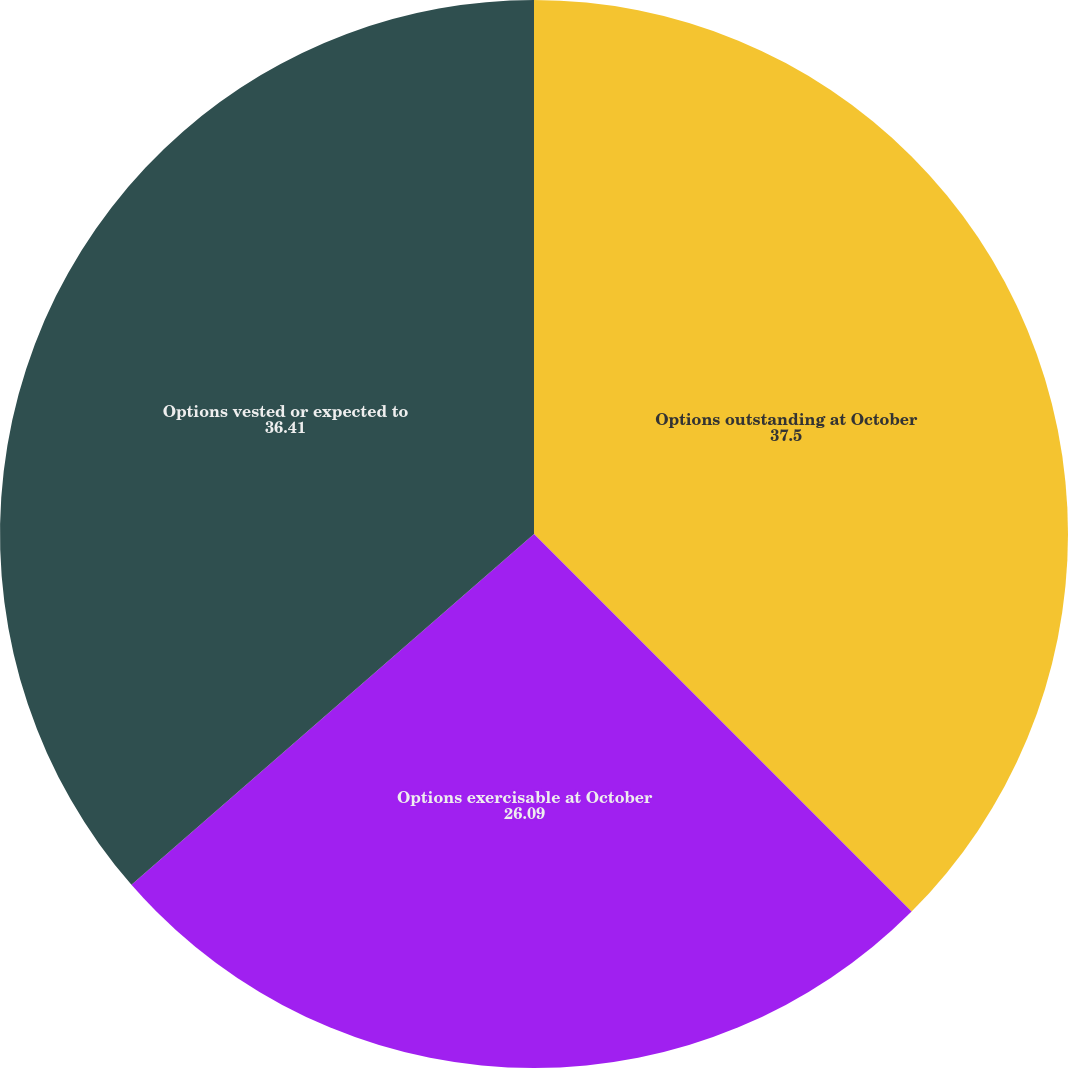Convert chart. <chart><loc_0><loc_0><loc_500><loc_500><pie_chart><fcel>Options outstanding at October<fcel>Options exercisable at October<fcel>Options vested or expected to<nl><fcel>37.5%<fcel>26.09%<fcel>36.41%<nl></chart> 